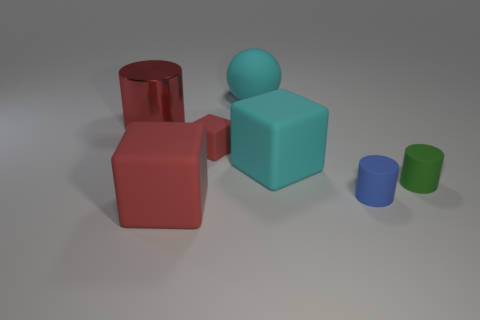What number of other things are there of the same shape as the large red rubber object?
Give a very brief answer. 2. There is a tiny object that is on the left side of the tiny green rubber thing and on the right side of the big rubber sphere; what shape is it?
Your response must be concise. Cylinder. What is the size of the red cube that is in front of the green matte thing?
Offer a very short reply. Large. Is the rubber sphere the same size as the blue rubber thing?
Offer a terse response. No. Are there fewer blue rubber things behind the small red matte cube than matte cylinders that are right of the tiny blue cylinder?
Make the answer very short. Yes. What size is the red object that is behind the large red rubber cube and in front of the red cylinder?
Your answer should be compact. Small. Are there any blocks on the right side of the small blue thing that is right of the large red object in front of the tiny cube?
Make the answer very short. No. Are there any green matte balls?
Offer a very short reply. No. Is the number of tiny red matte things in front of the big cyan ball greater than the number of large rubber spheres that are in front of the big cyan block?
Give a very brief answer. Yes. The cyan object that is the same material as the cyan block is what size?
Make the answer very short. Large. 